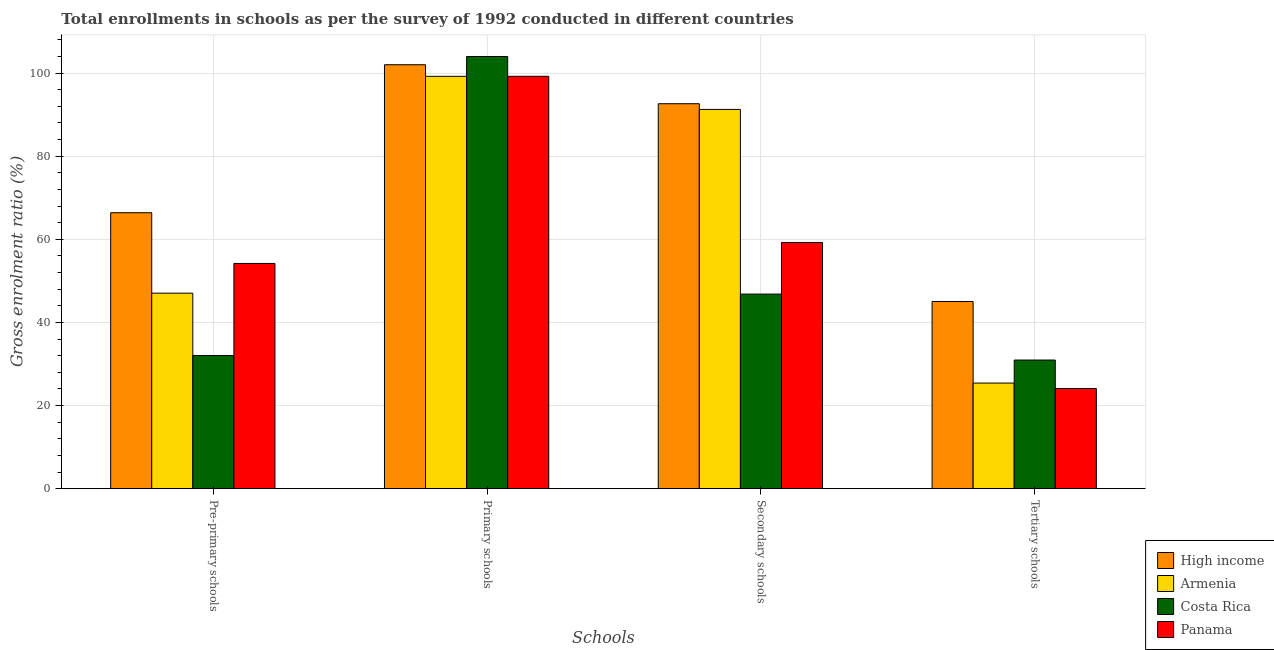How many different coloured bars are there?
Keep it short and to the point. 4. How many groups of bars are there?
Your response must be concise. 4. Are the number of bars on each tick of the X-axis equal?
Offer a terse response. Yes. How many bars are there on the 1st tick from the left?
Offer a very short reply. 4. What is the label of the 2nd group of bars from the left?
Your answer should be compact. Primary schools. What is the gross enrolment ratio in tertiary schools in Panama?
Keep it short and to the point. 24.1. Across all countries, what is the maximum gross enrolment ratio in tertiary schools?
Your answer should be compact. 45.04. Across all countries, what is the minimum gross enrolment ratio in secondary schools?
Your response must be concise. 46.82. In which country was the gross enrolment ratio in secondary schools minimum?
Provide a short and direct response. Costa Rica. What is the total gross enrolment ratio in primary schools in the graph?
Your response must be concise. 404.42. What is the difference between the gross enrolment ratio in secondary schools in Panama and that in Costa Rica?
Provide a succinct answer. 12.41. What is the difference between the gross enrolment ratio in secondary schools in High income and the gross enrolment ratio in tertiary schools in Armenia?
Make the answer very short. 67.21. What is the average gross enrolment ratio in pre-primary schools per country?
Give a very brief answer. 49.91. What is the difference between the gross enrolment ratio in secondary schools and gross enrolment ratio in pre-primary schools in Panama?
Ensure brevity in your answer.  5.04. In how many countries, is the gross enrolment ratio in secondary schools greater than 44 %?
Offer a very short reply. 4. What is the ratio of the gross enrolment ratio in tertiary schools in Costa Rica to that in Armenia?
Provide a short and direct response. 1.22. Is the gross enrolment ratio in tertiary schools in Armenia less than that in Costa Rica?
Make the answer very short. Yes. What is the difference between the highest and the second highest gross enrolment ratio in pre-primary schools?
Make the answer very short. 12.21. What is the difference between the highest and the lowest gross enrolment ratio in secondary schools?
Ensure brevity in your answer.  45.8. What does the 3rd bar from the left in Primary schools represents?
Your answer should be very brief. Costa Rica. What does the 1st bar from the right in Tertiary schools represents?
Make the answer very short. Panama. Is it the case that in every country, the sum of the gross enrolment ratio in pre-primary schools and gross enrolment ratio in primary schools is greater than the gross enrolment ratio in secondary schools?
Your response must be concise. Yes. What is the difference between two consecutive major ticks on the Y-axis?
Keep it short and to the point. 20. Does the graph contain grids?
Give a very brief answer. Yes. What is the title of the graph?
Your answer should be very brief. Total enrollments in schools as per the survey of 1992 conducted in different countries. What is the label or title of the X-axis?
Provide a succinct answer. Schools. What is the Gross enrolment ratio (%) in High income in Pre-primary schools?
Offer a very short reply. 66.39. What is the Gross enrolment ratio (%) in Armenia in Pre-primary schools?
Offer a very short reply. 47.04. What is the Gross enrolment ratio (%) of Costa Rica in Pre-primary schools?
Provide a short and direct response. 32.03. What is the Gross enrolment ratio (%) of Panama in Pre-primary schools?
Offer a very short reply. 54.19. What is the Gross enrolment ratio (%) of High income in Primary schools?
Your response must be concise. 102. What is the Gross enrolment ratio (%) in Armenia in Primary schools?
Provide a succinct answer. 99.21. What is the Gross enrolment ratio (%) of Costa Rica in Primary schools?
Offer a terse response. 103.98. What is the Gross enrolment ratio (%) in Panama in Primary schools?
Provide a short and direct response. 99.22. What is the Gross enrolment ratio (%) in High income in Secondary schools?
Ensure brevity in your answer.  92.62. What is the Gross enrolment ratio (%) in Armenia in Secondary schools?
Your response must be concise. 91.25. What is the Gross enrolment ratio (%) in Costa Rica in Secondary schools?
Your response must be concise. 46.82. What is the Gross enrolment ratio (%) in Panama in Secondary schools?
Your answer should be very brief. 59.23. What is the Gross enrolment ratio (%) of High income in Tertiary schools?
Give a very brief answer. 45.04. What is the Gross enrolment ratio (%) of Armenia in Tertiary schools?
Give a very brief answer. 25.41. What is the Gross enrolment ratio (%) in Costa Rica in Tertiary schools?
Give a very brief answer. 30.95. What is the Gross enrolment ratio (%) of Panama in Tertiary schools?
Provide a short and direct response. 24.1. Across all Schools, what is the maximum Gross enrolment ratio (%) of High income?
Ensure brevity in your answer.  102. Across all Schools, what is the maximum Gross enrolment ratio (%) of Armenia?
Provide a succinct answer. 99.21. Across all Schools, what is the maximum Gross enrolment ratio (%) of Costa Rica?
Your answer should be compact. 103.98. Across all Schools, what is the maximum Gross enrolment ratio (%) in Panama?
Give a very brief answer. 99.22. Across all Schools, what is the minimum Gross enrolment ratio (%) in High income?
Give a very brief answer. 45.04. Across all Schools, what is the minimum Gross enrolment ratio (%) of Armenia?
Your answer should be very brief. 25.41. Across all Schools, what is the minimum Gross enrolment ratio (%) of Costa Rica?
Your response must be concise. 30.95. Across all Schools, what is the minimum Gross enrolment ratio (%) of Panama?
Ensure brevity in your answer.  24.1. What is the total Gross enrolment ratio (%) of High income in the graph?
Offer a terse response. 306.05. What is the total Gross enrolment ratio (%) in Armenia in the graph?
Provide a short and direct response. 262.91. What is the total Gross enrolment ratio (%) of Costa Rica in the graph?
Provide a succinct answer. 213.78. What is the total Gross enrolment ratio (%) of Panama in the graph?
Make the answer very short. 236.73. What is the difference between the Gross enrolment ratio (%) of High income in Pre-primary schools and that in Primary schools?
Offer a terse response. -35.61. What is the difference between the Gross enrolment ratio (%) of Armenia in Pre-primary schools and that in Primary schools?
Provide a succinct answer. -52.17. What is the difference between the Gross enrolment ratio (%) in Costa Rica in Pre-primary schools and that in Primary schools?
Keep it short and to the point. -71.96. What is the difference between the Gross enrolment ratio (%) in Panama in Pre-primary schools and that in Primary schools?
Your answer should be very brief. -45.03. What is the difference between the Gross enrolment ratio (%) in High income in Pre-primary schools and that in Secondary schools?
Offer a very short reply. -26.23. What is the difference between the Gross enrolment ratio (%) in Armenia in Pre-primary schools and that in Secondary schools?
Your answer should be very brief. -44.21. What is the difference between the Gross enrolment ratio (%) of Costa Rica in Pre-primary schools and that in Secondary schools?
Make the answer very short. -14.79. What is the difference between the Gross enrolment ratio (%) in Panama in Pre-primary schools and that in Secondary schools?
Make the answer very short. -5.04. What is the difference between the Gross enrolment ratio (%) in High income in Pre-primary schools and that in Tertiary schools?
Keep it short and to the point. 21.35. What is the difference between the Gross enrolment ratio (%) in Armenia in Pre-primary schools and that in Tertiary schools?
Give a very brief answer. 21.63. What is the difference between the Gross enrolment ratio (%) in Costa Rica in Pre-primary schools and that in Tertiary schools?
Your answer should be compact. 1.08. What is the difference between the Gross enrolment ratio (%) of Panama in Pre-primary schools and that in Tertiary schools?
Your answer should be compact. 30.09. What is the difference between the Gross enrolment ratio (%) of High income in Primary schools and that in Secondary schools?
Your answer should be very brief. 9.38. What is the difference between the Gross enrolment ratio (%) of Armenia in Primary schools and that in Secondary schools?
Your answer should be compact. 7.96. What is the difference between the Gross enrolment ratio (%) in Costa Rica in Primary schools and that in Secondary schools?
Keep it short and to the point. 57.17. What is the difference between the Gross enrolment ratio (%) in Panama in Primary schools and that in Secondary schools?
Keep it short and to the point. 39.99. What is the difference between the Gross enrolment ratio (%) in High income in Primary schools and that in Tertiary schools?
Provide a succinct answer. 56.96. What is the difference between the Gross enrolment ratio (%) of Armenia in Primary schools and that in Tertiary schools?
Provide a succinct answer. 73.81. What is the difference between the Gross enrolment ratio (%) of Costa Rica in Primary schools and that in Tertiary schools?
Give a very brief answer. 73.03. What is the difference between the Gross enrolment ratio (%) of Panama in Primary schools and that in Tertiary schools?
Your answer should be compact. 75.12. What is the difference between the Gross enrolment ratio (%) of High income in Secondary schools and that in Tertiary schools?
Ensure brevity in your answer.  47.58. What is the difference between the Gross enrolment ratio (%) of Armenia in Secondary schools and that in Tertiary schools?
Keep it short and to the point. 65.84. What is the difference between the Gross enrolment ratio (%) of Costa Rica in Secondary schools and that in Tertiary schools?
Offer a terse response. 15.87. What is the difference between the Gross enrolment ratio (%) of Panama in Secondary schools and that in Tertiary schools?
Give a very brief answer. 35.13. What is the difference between the Gross enrolment ratio (%) of High income in Pre-primary schools and the Gross enrolment ratio (%) of Armenia in Primary schools?
Offer a terse response. -32.82. What is the difference between the Gross enrolment ratio (%) of High income in Pre-primary schools and the Gross enrolment ratio (%) of Costa Rica in Primary schools?
Offer a terse response. -37.59. What is the difference between the Gross enrolment ratio (%) of High income in Pre-primary schools and the Gross enrolment ratio (%) of Panama in Primary schools?
Make the answer very short. -32.83. What is the difference between the Gross enrolment ratio (%) in Armenia in Pre-primary schools and the Gross enrolment ratio (%) in Costa Rica in Primary schools?
Your response must be concise. -56.94. What is the difference between the Gross enrolment ratio (%) of Armenia in Pre-primary schools and the Gross enrolment ratio (%) of Panama in Primary schools?
Offer a terse response. -52.18. What is the difference between the Gross enrolment ratio (%) of Costa Rica in Pre-primary schools and the Gross enrolment ratio (%) of Panama in Primary schools?
Offer a very short reply. -67.19. What is the difference between the Gross enrolment ratio (%) of High income in Pre-primary schools and the Gross enrolment ratio (%) of Armenia in Secondary schools?
Keep it short and to the point. -24.86. What is the difference between the Gross enrolment ratio (%) of High income in Pre-primary schools and the Gross enrolment ratio (%) of Costa Rica in Secondary schools?
Your answer should be compact. 19.57. What is the difference between the Gross enrolment ratio (%) in High income in Pre-primary schools and the Gross enrolment ratio (%) in Panama in Secondary schools?
Keep it short and to the point. 7.16. What is the difference between the Gross enrolment ratio (%) in Armenia in Pre-primary schools and the Gross enrolment ratio (%) in Costa Rica in Secondary schools?
Keep it short and to the point. 0.22. What is the difference between the Gross enrolment ratio (%) in Armenia in Pre-primary schools and the Gross enrolment ratio (%) in Panama in Secondary schools?
Your response must be concise. -12.19. What is the difference between the Gross enrolment ratio (%) of Costa Rica in Pre-primary schools and the Gross enrolment ratio (%) of Panama in Secondary schools?
Make the answer very short. -27.2. What is the difference between the Gross enrolment ratio (%) of High income in Pre-primary schools and the Gross enrolment ratio (%) of Armenia in Tertiary schools?
Give a very brief answer. 40.98. What is the difference between the Gross enrolment ratio (%) of High income in Pre-primary schools and the Gross enrolment ratio (%) of Costa Rica in Tertiary schools?
Offer a very short reply. 35.44. What is the difference between the Gross enrolment ratio (%) in High income in Pre-primary schools and the Gross enrolment ratio (%) in Panama in Tertiary schools?
Provide a succinct answer. 42.29. What is the difference between the Gross enrolment ratio (%) in Armenia in Pre-primary schools and the Gross enrolment ratio (%) in Costa Rica in Tertiary schools?
Your answer should be very brief. 16.09. What is the difference between the Gross enrolment ratio (%) of Armenia in Pre-primary schools and the Gross enrolment ratio (%) of Panama in Tertiary schools?
Give a very brief answer. 22.94. What is the difference between the Gross enrolment ratio (%) in Costa Rica in Pre-primary schools and the Gross enrolment ratio (%) in Panama in Tertiary schools?
Offer a very short reply. 7.93. What is the difference between the Gross enrolment ratio (%) in High income in Primary schools and the Gross enrolment ratio (%) in Armenia in Secondary schools?
Your answer should be compact. 10.75. What is the difference between the Gross enrolment ratio (%) of High income in Primary schools and the Gross enrolment ratio (%) of Costa Rica in Secondary schools?
Your response must be concise. 55.18. What is the difference between the Gross enrolment ratio (%) of High income in Primary schools and the Gross enrolment ratio (%) of Panama in Secondary schools?
Your answer should be very brief. 42.77. What is the difference between the Gross enrolment ratio (%) of Armenia in Primary schools and the Gross enrolment ratio (%) of Costa Rica in Secondary schools?
Offer a very short reply. 52.39. What is the difference between the Gross enrolment ratio (%) in Armenia in Primary schools and the Gross enrolment ratio (%) in Panama in Secondary schools?
Your answer should be very brief. 39.98. What is the difference between the Gross enrolment ratio (%) of Costa Rica in Primary schools and the Gross enrolment ratio (%) of Panama in Secondary schools?
Your answer should be compact. 44.75. What is the difference between the Gross enrolment ratio (%) in High income in Primary schools and the Gross enrolment ratio (%) in Armenia in Tertiary schools?
Ensure brevity in your answer.  76.59. What is the difference between the Gross enrolment ratio (%) in High income in Primary schools and the Gross enrolment ratio (%) in Costa Rica in Tertiary schools?
Your answer should be compact. 71.05. What is the difference between the Gross enrolment ratio (%) in High income in Primary schools and the Gross enrolment ratio (%) in Panama in Tertiary schools?
Keep it short and to the point. 77.9. What is the difference between the Gross enrolment ratio (%) of Armenia in Primary schools and the Gross enrolment ratio (%) of Costa Rica in Tertiary schools?
Make the answer very short. 68.26. What is the difference between the Gross enrolment ratio (%) in Armenia in Primary schools and the Gross enrolment ratio (%) in Panama in Tertiary schools?
Provide a short and direct response. 75.11. What is the difference between the Gross enrolment ratio (%) of Costa Rica in Primary schools and the Gross enrolment ratio (%) of Panama in Tertiary schools?
Your response must be concise. 79.89. What is the difference between the Gross enrolment ratio (%) of High income in Secondary schools and the Gross enrolment ratio (%) of Armenia in Tertiary schools?
Provide a short and direct response. 67.21. What is the difference between the Gross enrolment ratio (%) in High income in Secondary schools and the Gross enrolment ratio (%) in Costa Rica in Tertiary schools?
Keep it short and to the point. 61.67. What is the difference between the Gross enrolment ratio (%) in High income in Secondary schools and the Gross enrolment ratio (%) in Panama in Tertiary schools?
Your answer should be compact. 68.52. What is the difference between the Gross enrolment ratio (%) in Armenia in Secondary schools and the Gross enrolment ratio (%) in Costa Rica in Tertiary schools?
Provide a succinct answer. 60.3. What is the difference between the Gross enrolment ratio (%) in Armenia in Secondary schools and the Gross enrolment ratio (%) in Panama in Tertiary schools?
Your answer should be very brief. 67.15. What is the difference between the Gross enrolment ratio (%) of Costa Rica in Secondary schools and the Gross enrolment ratio (%) of Panama in Tertiary schools?
Your answer should be compact. 22.72. What is the average Gross enrolment ratio (%) of High income per Schools?
Offer a very short reply. 76.51. What is the average Gross enrolment ratio (%) in Armenia per Schools?
Offer a very short reply. 65.73. What is the average Gross enrolment ratio (%) of Costa Rica per Schools?
Offer a very short reply. 53.45. What is the average Gross enrolment ratio (%) in Panama per Schools?
Provide a succinct answer. 59.18. What is the difference between the Gross enrolment ratio (%) of High income and Gross enrolment ratio (%) of Armenia in Pre-primary schools?
Provide a succinct answer. 19.35. What is the difference between the Gross enrolment ratio (%) in High income and Gross enrolment ratio (%) in Costa Rica in Pre-primary schools?
Your answer should be very brief. 34.36. What is the difference between the Gross enrolment ratio (%) in High income and Gross enrolment ratio (%) in Panama in Pre-primary schools?
Offer a terse response. 12.21. What is the difference between the Gross enrolment ratio (%) of Armenia and Gross enrolment ratio (%) of Costa Rica in Pre-primary schools?
Give a very brief answer. 15.01. What is the difference between the Gross enrolment ratio (%) in Armenia and Gross enrolment ratio (%) in Panama in Pre-primary schools?
Make the answer very short. -7.15. What is the difference between the Gross enrolment ratio (%) in Costa Rica and Gross enrolment ratio (%) in Panama in Pre-primary schools?
Provide a succinct answer. -22.16. What is the difference between the Gross enrolment ratio (%) of High income and Gross enrolment ratio (%) of Armenia in Primary schools?
Ensure brevity in your answer.  2.79. What is the difference between the Gross enrolment ratio (%) in High income and Gross enrolment ratio (%) in Costa Rica in Primary schools?
Your answer should be very brief. -1.98. What is the difference between the Gross enrolment ratio (%) of High income and Gross enrolment ratio (%) of Panama in Primary schools?
Ensure brevity in your answer.  2.78. What is the difference between the Gross enrolment ratio (%) in Armenia and Gross enrolment ratio (%) in Costa Rica in Primary schools?
Your answer should be very brief. -4.77. What is the difference between the Gross enrolment ratio (%) of Armenia and Gross enrolment ratio (%) of Panama in Primary schools?
Provide a succinct answer. -0.01. What is the difference between the Gross enrolment ratio (%) of Costa Rica and Gross enrolment ratio (%) of Panama in Primary schools?
Make the answer very short. 4.76. What is the difference between the Gross enrolment ratio (%) in High income and Gross enrolment ratio (%) in Armenia in Secondary schools?
Provide a succinct answer. 1.37. What is the difference between the Gross enrolment ratio (%) in High income and Gross enrolment ratio (%) in Costa Rica in Secondary schools?
Provide a short and direct response. 45.8. What is the difference between the Gross enrolment ratio (%) in High income and Gross enrolment ratio (%) in Panama in Secondary schools?
Offer a terse response. 33.39. What is the difference between the Gross enrolment ratio (%) of Armenia and Gross enrolment ratio (%) of Costa Rica in Secondary schools?
Offer a very short reply. 44.43. What is the difference between the Gross enrolment ratio (%) in Armenia and Gross enrolment ratio (%) in Panama in Secondary schools?
Make the answer very short. 32.02. What is the difference between the Gross enrolment ratio (%) of Costa Rica and Gross enrolment ratio (%) of Panama in Secondary schools?
Give a very brief answer. -12.41. What is the difference between the Gross enrolment ratio (%) of High income and Gross enrolment ratio (%) of Armenia in Tertiary schools?
Make the answer very short. 19.63. What is the difference between the Gross enrolment ratio (%) of High income and Gross enrolment ratio (%) of Costa Rica in Tertiary schools?
Offer a very short reply. 14.09. What is the difference between the Gross enrolment ratio (%) in High income and Gross enrolment ratio (%) in Panama in Tertiary schools?
Keep it short and to the point. 20.94. What is the difference between the Gross enrolment ratio (%) of Armenia and Gross enrolment ratio (%) of Costa Rica in Tertiary schools?
Make the answer very short. -5.54. What is the difference between the Gross enrolment ratio (%) of Armenia and Gross enrolment ratio (%) of Panama in Tertiary schools?
Offer a very short reply. 1.31. What is the difference between the Gross enrolment ratio (%) of Costa Rica and Gross enrolment ratio (%) of Panama in Tertiary schools?
Make the answer very short. 6.85. What is the ratio of the Gross enrolment ratio (%) in High income in Pre-primary schools to that in Primary schools?
Your response must be concise. 0.65. What is the ratio of the Gross enrolment ratio (%) of Armenia in Pre-primary schools to that in Primary schools?
Your response must be concise. 0.47. What is the ratio of the Gross enrolment ratio (%) of Costa Rica in Pre-primary schools to that in Primary schools?
Provide a short and direct response. 0.31. What is the ratio of the Gross enrolment ratio (%) of Panama in Pre-primary schools to that in Primary schools?
Give a very brief answer. 0.55. What is the ratio of the Gross enrolment ratio (%) in High income in Pre-primary schools to that in Secondary schools?
Give a very brief answer. 0.72. What is the ratio of the Gross enrolment ratio (%) of Armenia in Pre-primary schools to that in Secondary schools?
Provide a succinct answer. 0.52. What is the ratio of the Gross enrolment ratio (%) of Costa Rica in Pre-primary schools to that in Secondary schools?
Your answer should be compact. 0.68. What is the ratio of the Gross enrolment ratio (%) in Panama in Pre-primary schools to that in Secondary schools?
Offer a very short reply. 0.91. What is the ratio of the Gross enrolment ratio (%) of High income in Pre-primary schools to that in Tertiary schools?
Keep it short and to the point. 1.47. What is the ratio of the Gross enrolment ratio (%) of Armenia in Pre-primary schools to that in Tertiary schools?
Offer a terse response. 1.85. What is the ratio of the Gross enrolment ratio (%) in Costa Rica in Pre-primary schools to that in Tertiary schools?
Your response must be concise. 1.03. What is the ratio of the Gross enrolment ratio (%) in Panama in Pre-primary schools to that in Tertiary schools?
Offer a terse response. 2.25. What is the ratio of the Gross enrolment ratio (%) in High income in Primary schools to that in Secondary schools?
Offer a very short reply. 1.1. What is the ratio of the Gross enrolment ratio (%) in Armenia in Primary schools to that in Secondary schools?
Keep it short and to the point. 1.09. What is the ratio of the Gross enrolment ratio (%) of Costa Rica in Primary schools to that in Secondary schools?
Make the answer very short. 2.22. What is the ratio of the Gross enrolment ratio (%) of Panama in Primary schools to that in Secondary schools?
Your response must be concise. 1.68. What is the ratio of the Gross enrolment ratio (%) in High income in Primary schools to that in Tertiary schools?
Provide a succinct answer. 2.26. What is the ratio of the Gross enrolment ratio (%) of Armenia in Primary schools to that in Tertiary schools?
Provide a short and direct response. 3.9. What is the ratio of the Gross enrolment ratio (%) in Costa Rica in Primary schools to that in Tertiary schools?
Ensure brevity in your answer.  3.36. What is the ratio of the Gross enrolment ratio (%) in Panama in Primary schools to that in Tertiary schools?
Provide a succinct answer. 4.12. What is the ratio of the Gross enrolment ratio (%) in High income in Secondary schools to that in Tertiary schools?
Make the answer very short. 2.06. What is the ratio of the Gross enrolment ratio (%) of Armenia in Secondary schools to that in Tertiary schools?
Keep it short and to the point. 3.59. What is the ratio of the Gross enrolment ratio (%) in Costa Rica in Secondary schools to that in Tertiary schools?
Ensure brevity in your answer.  1.51. What is the ratio of the Gross enrolment ratio (%) in Panama in Secondary schools to that in Tertiary schools?
Ensure brevity in your answer.  2.46. What is the difference between the highest and the second highest Gross enrolment ratio (%) of High income?
Provide a short and direct response. 9.38. What is the difference between the highest and the second highest Gross enrolment ratio (%) of Armenia?
Your answer should be very brief. 7.96. What is the difference between the highest and the second highest Gross enrolment ratio (%) in Costa Rica?
Make the answer very short. 57.17. What is the difference between the highest and the second highest Gross enrolment ratio (%) in Panama?
Make the answer very short. 39.99. What is the difference between the highest and the lowest Gross enrolment ratio (%) in High income?
Offer a terse response. 56.96. What is the difference between the highest and the lowest Gross enrolment ratio (%) of Armenia?
Offer a terse response. 73.81. What is the difference between the highest and the lowest Gross enrolment ratio (%) of Costa Rica?
Your answer should be compact. 73.03. What is the difference between the highest and the lowest Gross enrolment ratio (%) of Panama?
Provide a succinct answer. 75.12. 